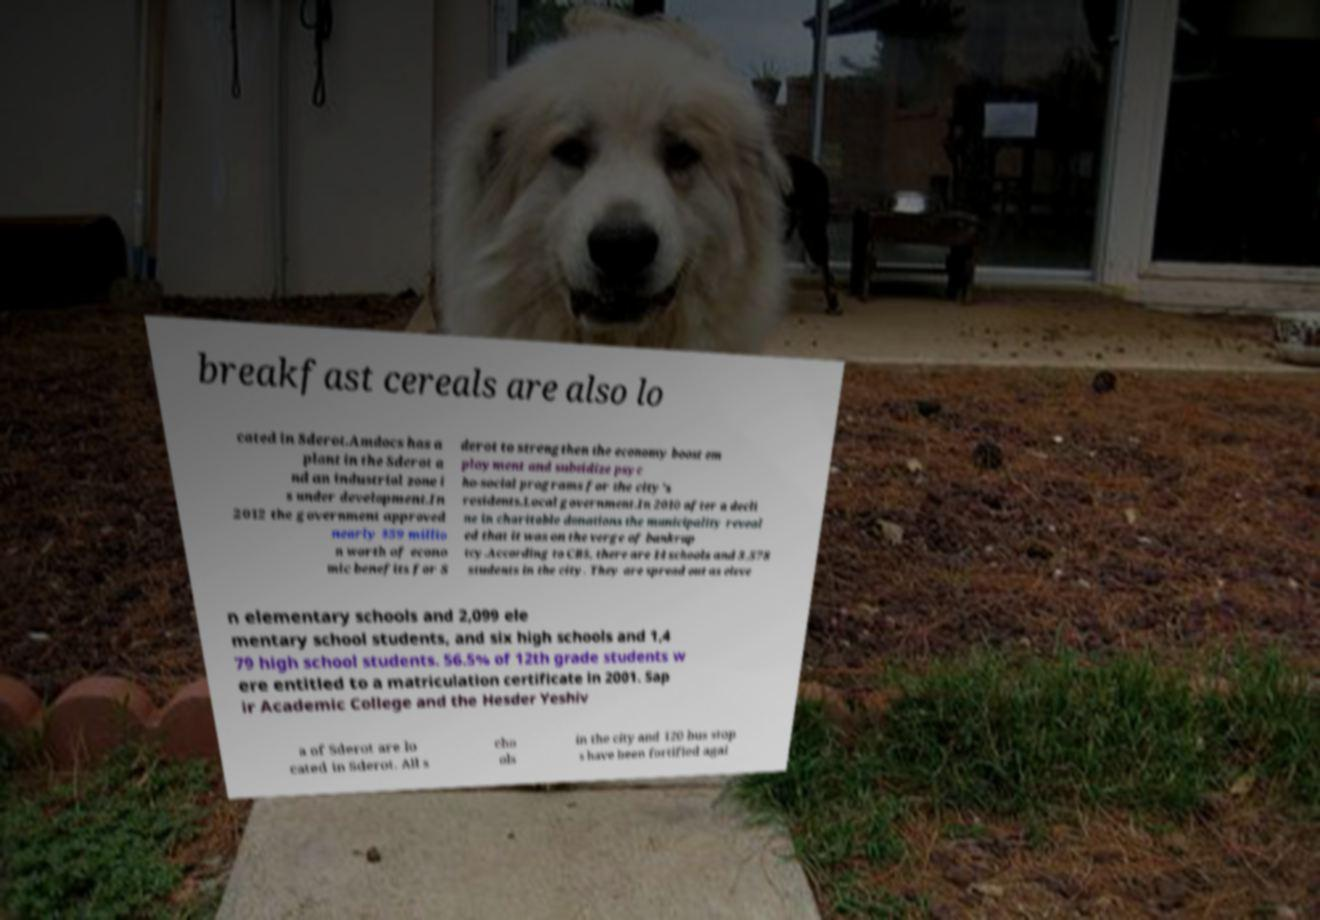Can you read and provide the text displayed in the image?This photo seems to have some interesting text. Can you extract and type it out for me? breakfast cereals are also lo cated in Sderot.Amdocs has a plant in the Sderot a nd an industrial zone i s under development.In 2012 the government approved nearly $59 millio n worth of econo mic benefits for S derot to strengthen the economy boost em ployment and subsidize psyc ho-social programs for the city's residents.Local government.In 2010 after a decli ne in charitable donations the municipality reveal ed that it was on the verge of bankrup tcy.According to CBS, there are 14 schools and 3,578 students in the city. They are spread out as eleve n elementary schools and 2,099 ele mentary school students, and six high schools and 1,4 79 high school students. 56.5% of 12th grade students w ere entitled to a matriculation certificate in 2001. Sap ir Academic College and the Hesder Yeshiv a of Sderot are lo cated in Sderot. All s cho ols in the city and 120 bus stop s have been fortified agai 